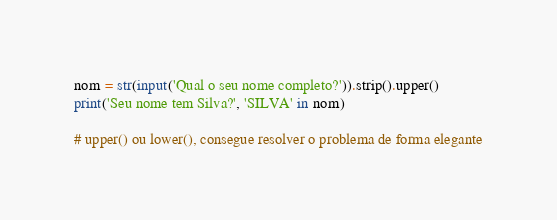Convert code to text. <code><loc_0><loc_0><loc_500><loc_500><_Python_>nom = str(input('Qual o seu nome completo?')).strip().upper()
print('Seu nome tem Silva?', 'SILVA' in nom)

# upper() ou lower(), consegue resolver o problema de forma elegante
</code> 